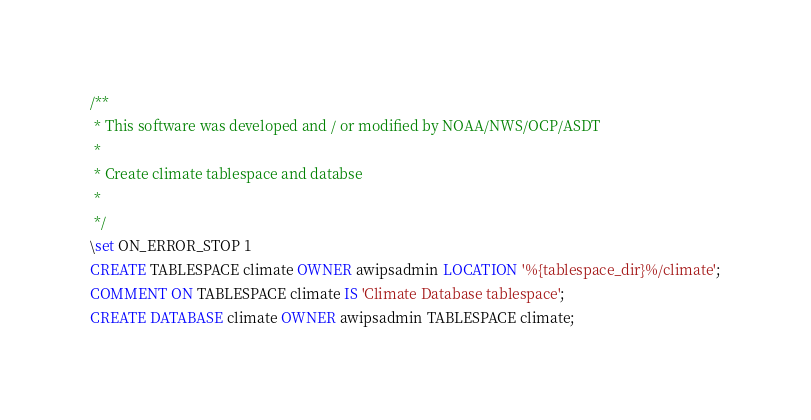Convert code to text. <code><loc_0><loc_0><loc_500><loc_500><_SQL_>/**
 * This software was developed and / or modified by NOAA/NWS/OCP/ASDT
 *
 * Create climate tablespace and databse 
 * 
 */
\set ON_ERROR_STOP 1
CREATE TABLESPACE climate OWNER awipsadmin LOCATION '%{tablespace_dir}%/climate';
COMMENT ON TABLESPACE climate IS 'Climate Database tablespace';
CREATE DATABASE climate OWNER awipsadmin TABLESPACE climate;</code> 